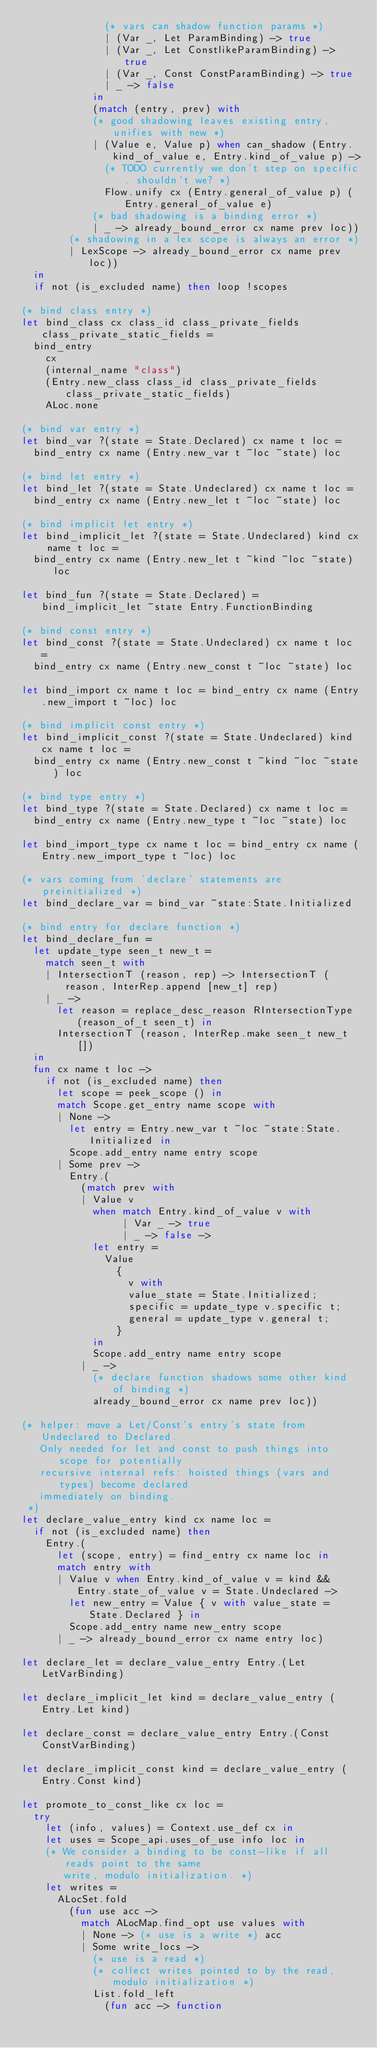Convert code to text. <code><loc_0><loc_0><loc_500><loc_500><_OCaml_>              (* vars can shadow function params *)
              | (Var _, Let ParamBinding) -> true
              | (Var _, Let ConstlikeParamBinding) -> true
              | (Var _, Const ConstParamBinding) -> true
              | _ -> false
            in
            (match (entry, prev) with
            (* good shadowing leaves existing entry, unifies with new *)
            | (Value e, Value p) when can_shadow (Entry.kind_of_value e, Entry.kind_of_value p) ->
              (* TODO currently we don't step on specific. shouldn't we? *)
              Flow.unify cx (Entry.general_of_value p) (Entry.general_of_value e)
            (* bad shadowing is a binding error *)
            | _ -> already_bound_error cx name prev loc))
        (* shadowing in a lex scope is always an error *)
        | LexScope -> already_bound_error cx name prev loc))
  in
  if not (is_excluded name) then loop !scopes

(* bind class entry *)
let bind_class cx class_id class_private_fields class_private_static_fields =
  bind_entry
    cx
    (internal_name "class")
    (Entry.new_class class_id class_private_fields class_private_static_fields)
    ALoc.none

(* bind var entry *)
let bind_var ?(state = State.Declared) cx name t loc =
  bind_entry cx name (Entry.new_var t ~loc ~state) loc

(* bind let entry *)
let bind_let ?(state = State.Undeclared) cx name t loc =
  bind_entry cx name (Entry.new_let t ~loc ~state) loc

(* bind implicit let entry *)
let bind_implicit_let ?(state = State.Undeclared) kind cx name t loc =
  bind_entry cx name (Entry.new_let t ~kind ~loc ~state) loc

let bind_fun ?(state = State.Declared) = bind_implicit_let ~state Entry.FunctionBinding

(* bind const entry *)
let bind_const ?(state = State.Undeclared) cx name t loc =
  bind_entry cx name (Entry.new_const t ~loc ~state) loc

let bind_import cx name t loc = bind_entry cx name (Entry.new_import t ~loc) loc

(* bind implicit const entry *)
let bind_implicit_const ?(state = State.Undeclared) kind cx name t loc =
  bind_entry cx name (Entry.new_const t ~kind ~loc ~state) loc

(* bind type entry *)
let bind_type ?(state = State.Declared) cx name t loc =
  bind_entry cx name (Entry.new_type t ~loc ~state) loc

let bind_import_type cx name t loc = bind_entry cx name (Entry.new_import_type t ~loc) loc

(* vars coming from 'declare' statements are preinitialized *)
let bind_declare_var = bind_var ~state:State.Initialized

(* bind entry for declare function *)
let bind_declare_fun =
  let update_type seen_t new_t =
    match seen_t with
    | IntersectionT (reason, rep) -> IntersectionT (reason, InterRep.append [new_t] rep)
    | _ ->
      let reason = replace_desc_reason RIntersectionType (reason_of_t seen_t) in
      IntersectionT (reason, InterRep.make seen_t new_t [])
  in
  fun cx name t loc ->
    if not (is_excluded name) then
      let scope = peek_scope () in
      match Scope.get_entry name scope with
      | None ->
        let entry = Entry.new_var t ~loc ~state:State.Initialized in
        Scope.add_entry name entry scope
      | Some prev ->
        Entry.(
          (match prev with
          | Value v
            when match Entry.kind_of_value v with
                 | Var _ -> true
                 | _ -> false ->
            let entry =
              Value
                {
                  v with
                  value_state = State.Initialized;
                  specific = update_type v.specific t;
                  general = update_type v.general t;
                }
            in
            Scope.add_entry name entry scope
          | _ ->
            (* declare function shadows some other kind of binding *)
            already_bound_error cx name prev loc))

(* helper: move a Let/Const's entry's state from Undeclared to Declared.
   Only needed for let and const to push things into scope for potentially
   recursive internal refs: hoisted things (vars and types) become declared
   immediately on binding.
 *)
let declare_value_entry kind cx name loc =
  if not (is_excluded name) then
    Entry.(
      let (scope, entry) = find_entry cx name loc in
      match entry with
      | Value v when Entry.kind_of_value v = kind && Entry.state_of_value v = State.Undeclared ->
        let new_entry = Value { v with value_state = State.Declared } in
        Scope.add_entry name new_entry scope
      | _ -> already_bound_error cx name entry loc)

let declare_let = declare_value_entry Entry.(Let LetVarBinding)

let declare_implicit_let kind = declare_value_entry (Entry.Let kind)

let declare_const = declare_value_entry Entry.(Const ConstVarBinding)

let declare_implicit_const kind = declare_value_entry (Entry.Const kind)

let promote_to_const_like cx loc =
  try
    let (info, values) = Context.use_def cx in
    let uses = Scope_api.uses_of_use info loc in
    (* We consider a binding to be const-like if all reads point to the same
       write, modulo initialization. *)
    let writes =
      ALocSet.fold
        (fun use acc ->
          match ALocMap.find_opt use values with
          | None -> (* use is a write *) acc
          | Some write_locs ->
            (* use is a read *)
            (* collect writes pointed to by the read, modulo initialization *)
            List.fold_left
              (fun acc -> function</code> 